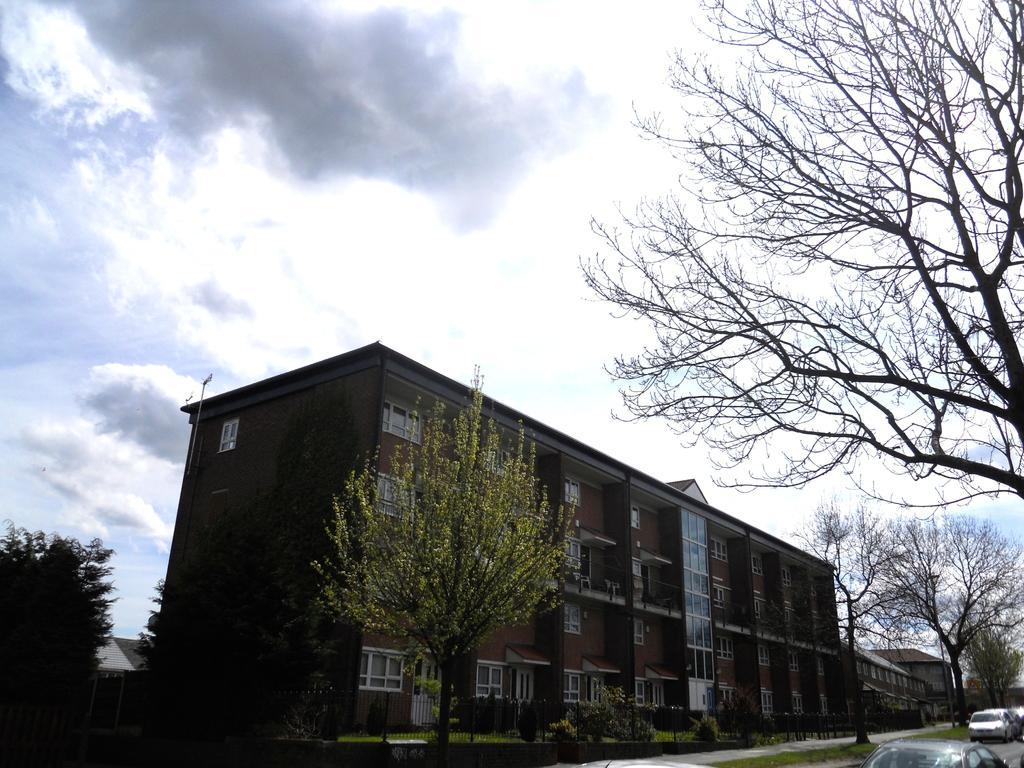How would you summarize this image in a sentence or two? There is a building and beside the building there are some houses and there are plenty of trees and there are some vehicles moving on the road and in the background there is a sky. 